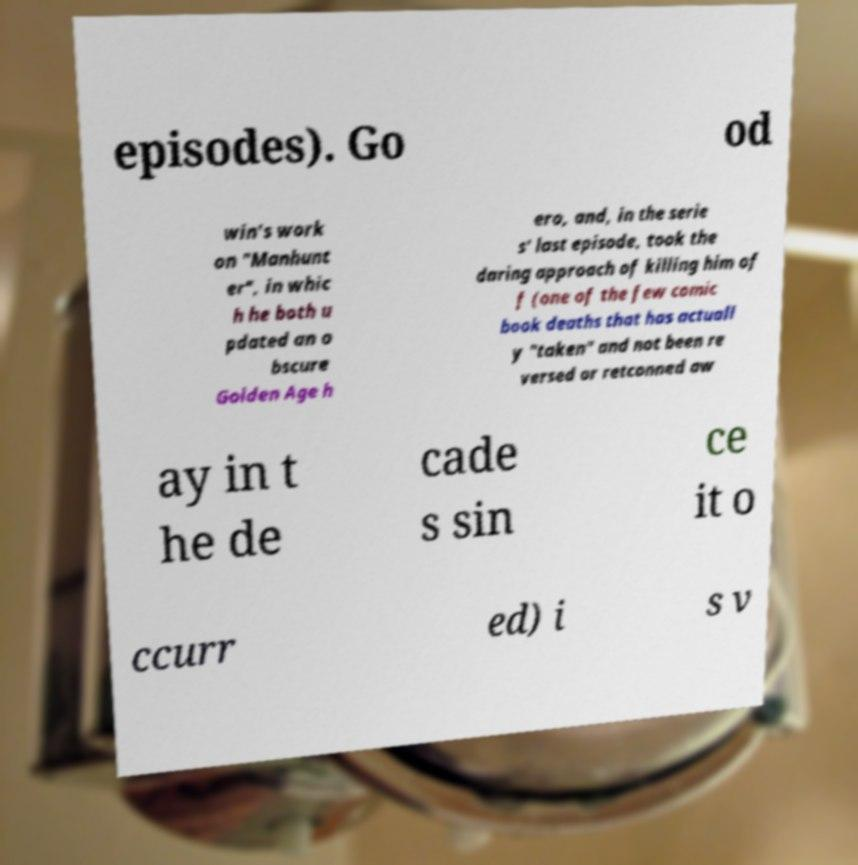Could you extract and type out the text from this image? episodes). Go od win's work on "Manhunt er", in whic h he both u pdated an o bscure Golden Age h ero, and, in the serie s' last episode, took the daring approach of killing him of f (one of the few comic book deaths that has actuall y "taken" and not been re versed or retconned aw ay in t he de cade s sin ce it o ccurr ed) i s v 